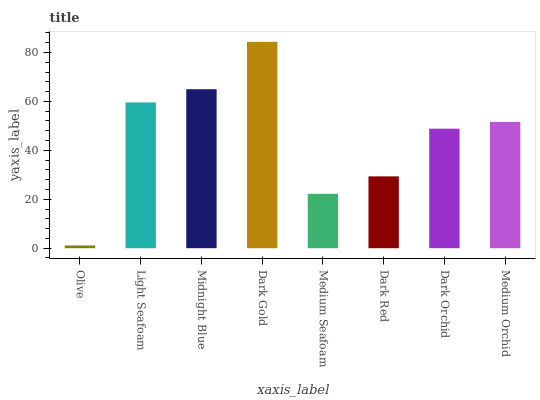Is Light Seafoam the minimum?
Answer yes or no. No. Is Light Seafoam the maximum?
Answer yes or no. No. Is Light Seafoam greater than Olive?
Answer yes or no. Yes. Is Olive less than Light Seafoam?
Answer yes or no. Yes. Is Olive greater than Light Seafoam?
Answer yes or no. No. Is Light Seafoam less than Olive?
Answer yes or no. No. Is Medium Orchid the high median?
Answer yes or no. Yes. Is Dark Orchid the low median?
Answer yes or no. Yes. Is Medium Seafoam the high median?
Answer yes or no. No. Is Light Seafoam the low median?
Answer yes or no. No. 